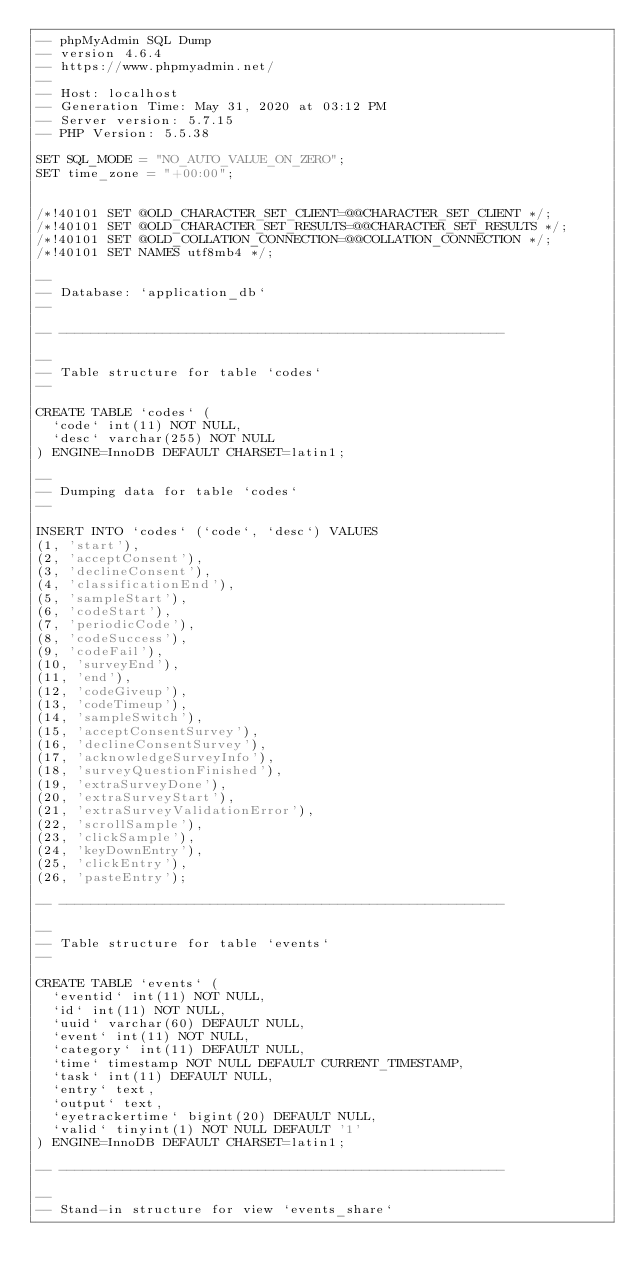<code> <loc_0><loc_0><loc_500><loc_500><_SQL_>-- phpMyAdmin SQL Dump
-- version 4.6.4
-- https://www.phpmyadmin.net/
--
-- Host: localhost
-- Generation Time: May 31, 2020 at 03:12 PM
-- Server version: 5.7.15
-- PHP Version: 5.5.38

SET SQL_MODE = "NO_AUTO_VALUE_ON_ZERO";
SET time_zone = "+00:00";


/*!40101 SET @OLD_CHARACTER_SET_CLIENT=@@CHARACTER_SET_CLIENT */;
/*!40101 SET @OLD_CHARACTER_SET_RESULTS=@@CHARACTER_SET_RESULTS */;
/*!40101 SET @OLD_COLLATION_CONNECTION=@@COLLATION_CONNECTION */;
/*!40101 SET NAMES utf8mb4 */;

--
-- Database: `application_db`
--

-- --------------------------------------------------------

--
-- Table structure for table `codes`
--

CREATE TABLE `codes` (
  `code` int(11) NOT NULL,
  `desc` varchar(255) NOT NULL
) ENGINE=InnoDB DEFAULT CHARSET=latin1;

--
-- Dumping data for table `codes`
--

INSERT INTO `codes` (`code`, `desc`) VALUES
(1, 'start'),
(2, 'acceptConsent'),
(3, 'declineConsent'),
(4, 'classificationEnd'),
(5, 'sampleStart'),
(6, 'codeStart'),
(7, 'periodicCode'),
(8, 'codeSuccess'),
(9, 'codeFail'),
(10, 'surveyEnd'),
(11, 'end'),
(12, 'codeGiveup'),
(13, 'codeTimeup'),
(14, 'sampleSwitch'),
(15, 'acceptConsentSurvey'),
(16, 'declineConsentSurvey'),
(17, 'acknowledgeSurveyInfo'),
(18, 'surveyQuestionFinished'),
(19, 'extraSurveyDone'),
(20, 'extraSurveyStart'),
(21, 'extraSurveyValidationError'),
(22, 'scrollSample'),
(23, 'clickSample'),
(24, 'keyDownEntry'),
(25, 'clickEntry'),
(26, 'pasteEntry');

-- --------------------------------------------------------

--
-- Table structure for table `events`
--

CREATE TABLE `events` (
  `eventid` int(11) NOT NULL,
  `id` int(11) NOT NULL,
  `uuid` varchar(60) DEFAULT NULL,
  `event` int(11) NOT NULL,
  `category` int(11) DEFAULT NULL,
  `time` timestamp NOT NULL DEFAULT CURRENT_TIMESTAMP,
  `task` int(11) DEFAULT NULL,
  `entry` text,
  `output` text,
  `eyetrackertime` bigint(20) DEFAULT NULL,
  `valid` tinyint(1) NOT NULL DEFAULT '1'
) ENGINE=InnoDB DEFAULT CHARSET=latin1;

-- --------------------------------------------------------

--
-- Stand-in structure for view `events_share`</code> 